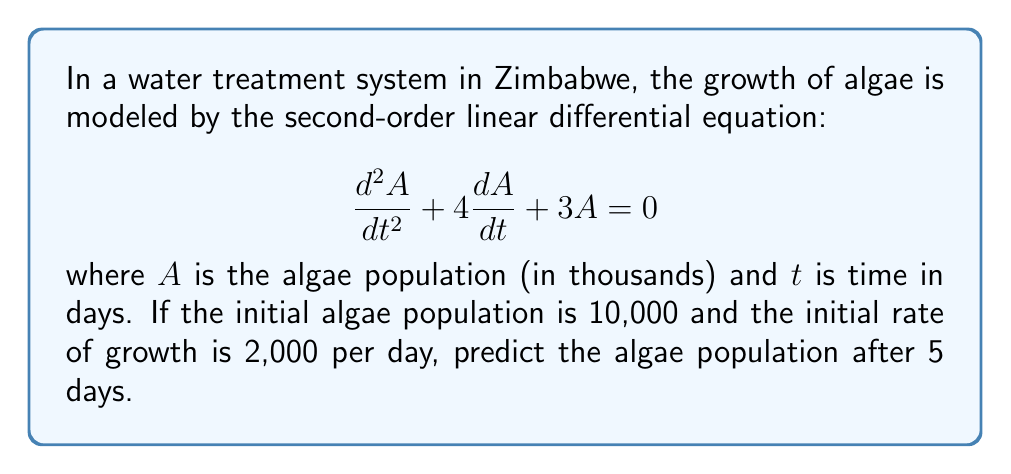Could you help me with this problem? To solve this problem, we need to follow these steps:

1) The general solution for this second-order linear differential equation is:

   $$A(t) = c_1e^{-t} + c_2e^{-3t}$$

2) We need to find $c_1$ and $c_2$ using the initial conditions:
   
   At $t=0$, $A(0) = 10$ (remember, A is in thousands)
   At $t=0$, $\frac{dA}{dt}(0) = 2$ (also in thousands)

3) Using the first condition:

   $$10 = c_1 + c_2$$

4) For the second condition, we differentiate $A(t)$:

   $$\frac{dA}{dt} = -c_1e^{-t} - 3c_2e^{-3t}$$

   At $t=0$:
   
   $$2 = -c_1 - 3c_2$$

5) Now we have a system of two equations:

   $$c_1 + c_2 = 10$$
   $$c_1 + 3c_2 = -2$$

6) Subtracting the second equation from the first:

   $$-2c_2 = 12$$
   $$c_2 = -6$$

7) Substituting back into the first equation:

   $$c_1 - 6 = 10$$
   $$c_1 = 16$$

8) Now we have our particular solution:

   $$A(t) = 16e^{-t} - 6e^{-3t}$$

9) To find the algae population after 5 days, we evaluate $A(5)$:

   $$A(5) = 16e^{-5} - 6e^{-15}$$

10) Using a calculator:

    $$A(5) \approx 0.5353 - 0.0000 \approx 0.5353$$

Remember, this is in thousands, so the actual population is about 535.3 algae.
Answer: The algae population after 5 days will be approximately 535 (rounded to the nearest whole number). 